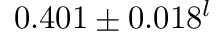Convert formula to latex. <formula><loc_0><loc_0><loc_500><loc_500>0 . 4 0 1 \pm 0 . 0 1 8 ^ { l }</formula> 